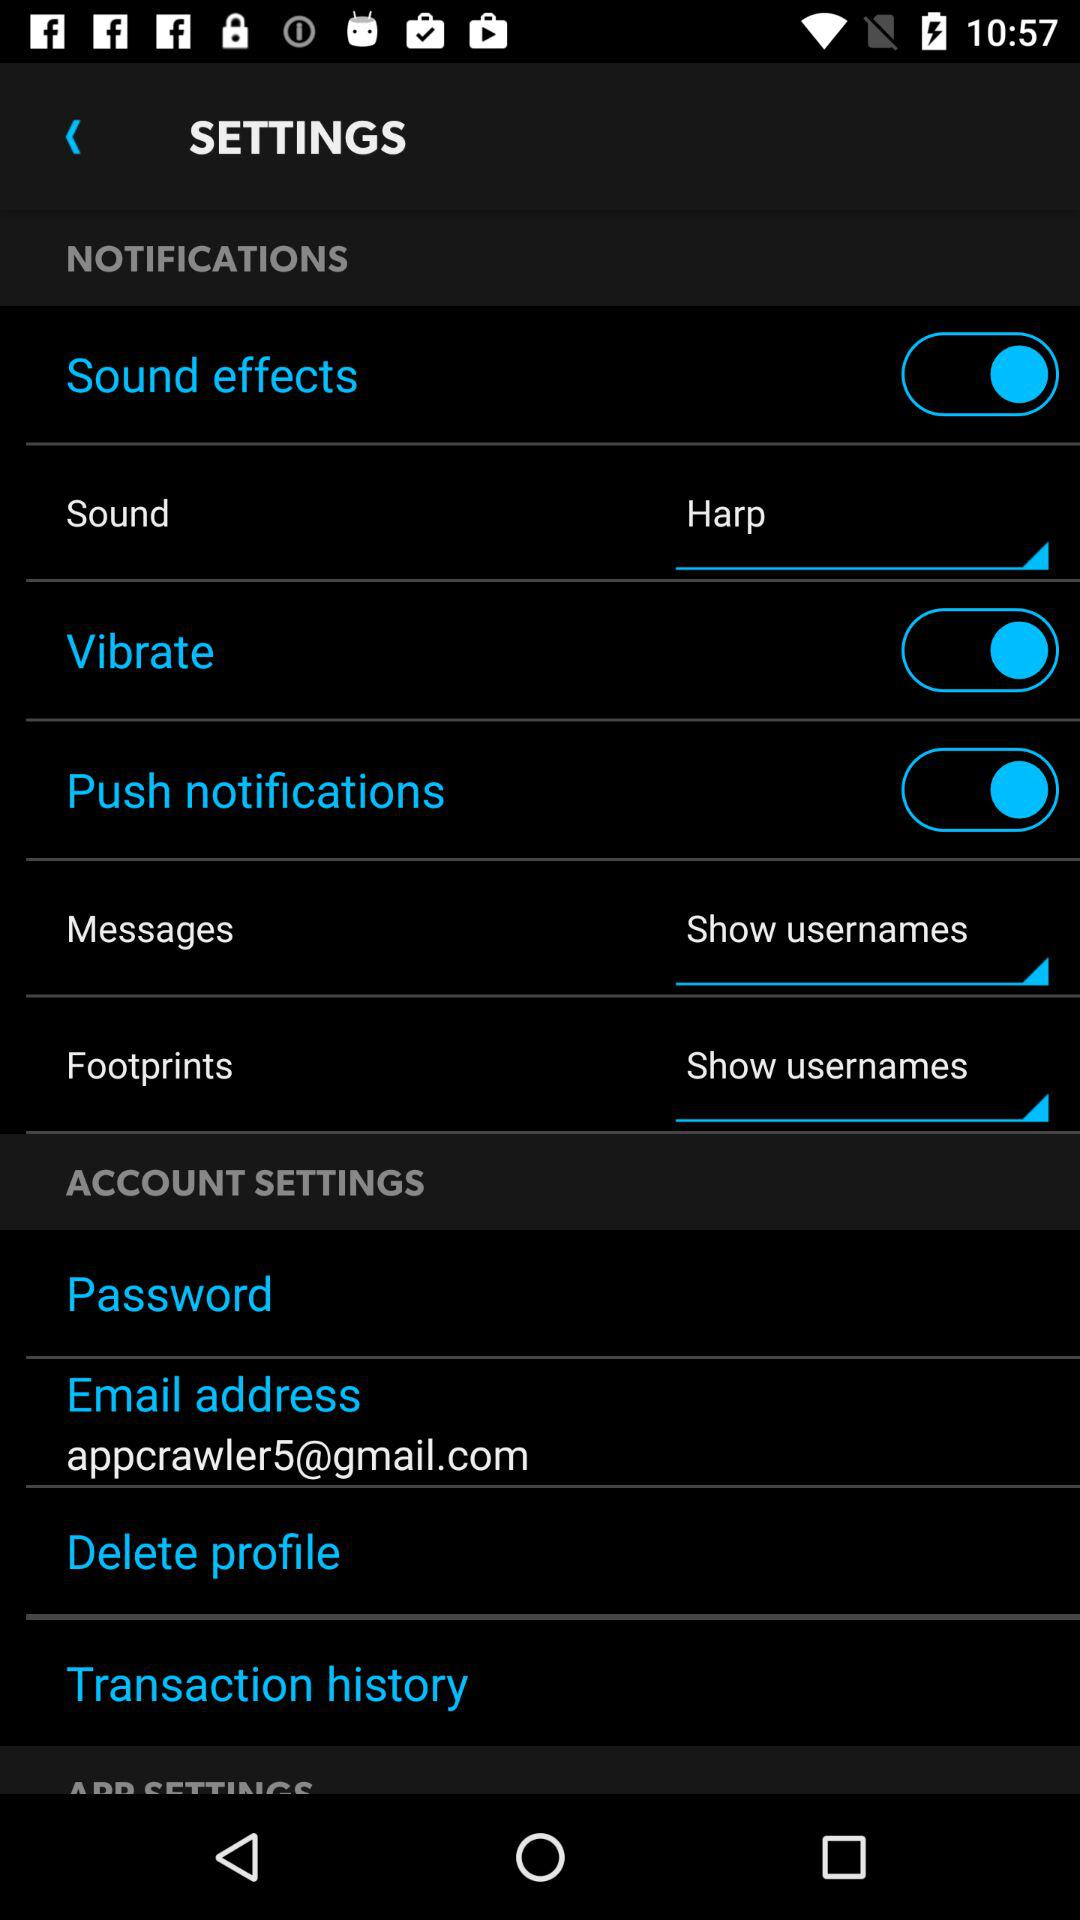What is the status of the "Push notifications" setting? The status is "on". 